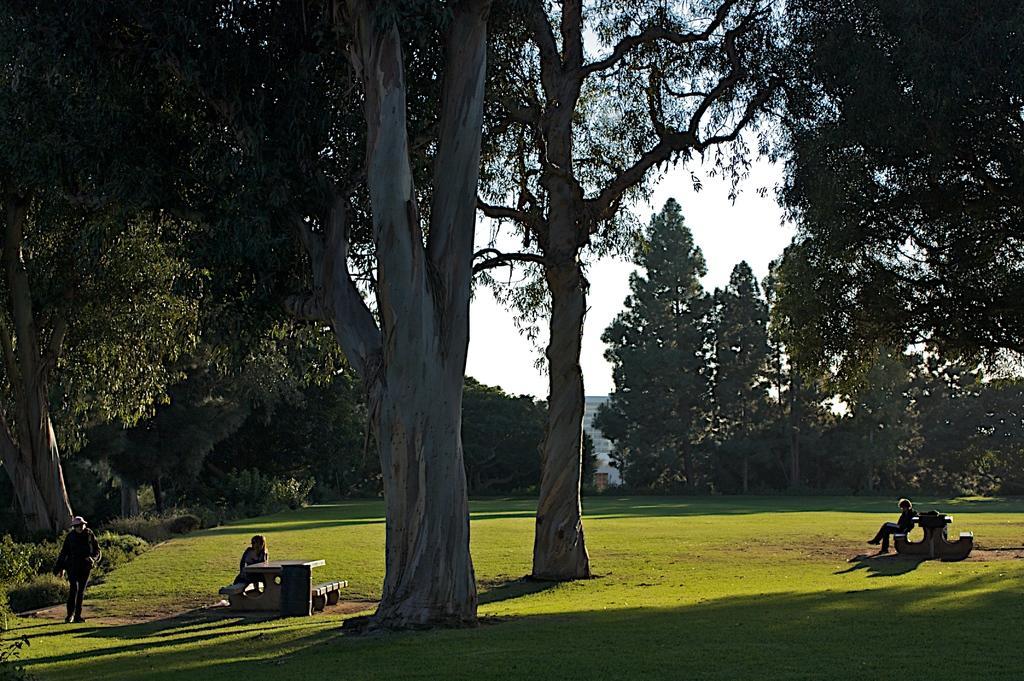In one or two sentences, can you explain what this image depicts? In this image we can see there are two persons sitting on the bench and the other person walking on the ground. And there are trees, grass, building and sky in the background. 